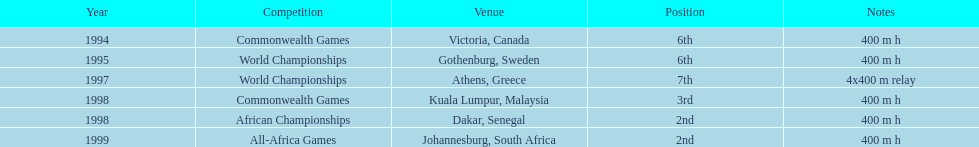Could you parse the entire table? {'header': ['Year', 'Competition', 'Venue', 'Position', 'Notes'], 'rows': [['1994', 'Commonwealth Games', 'Victoria, Canada', '6th', '400 m h'], ['1995', 'World Championships', 'Gothenburg, Sweden', '6th', '400 m h'], ['1997', 'World Championships', 'Athens, Greece', '7th', '4x400 m relay'], ['1998', 'Commonwealth Games', 'Kuala Lumpur, Malaysia', '3rd', '400 m h'], ['1998', 'African Championships', 'Dakar, Senegal', '2nd', '400 m h'], ['1999', 'All-Africa Games', 'Johannesburg, South Africa', '2nd', '400 m h']]} What is the name of the last competition? All-Africa Games. 